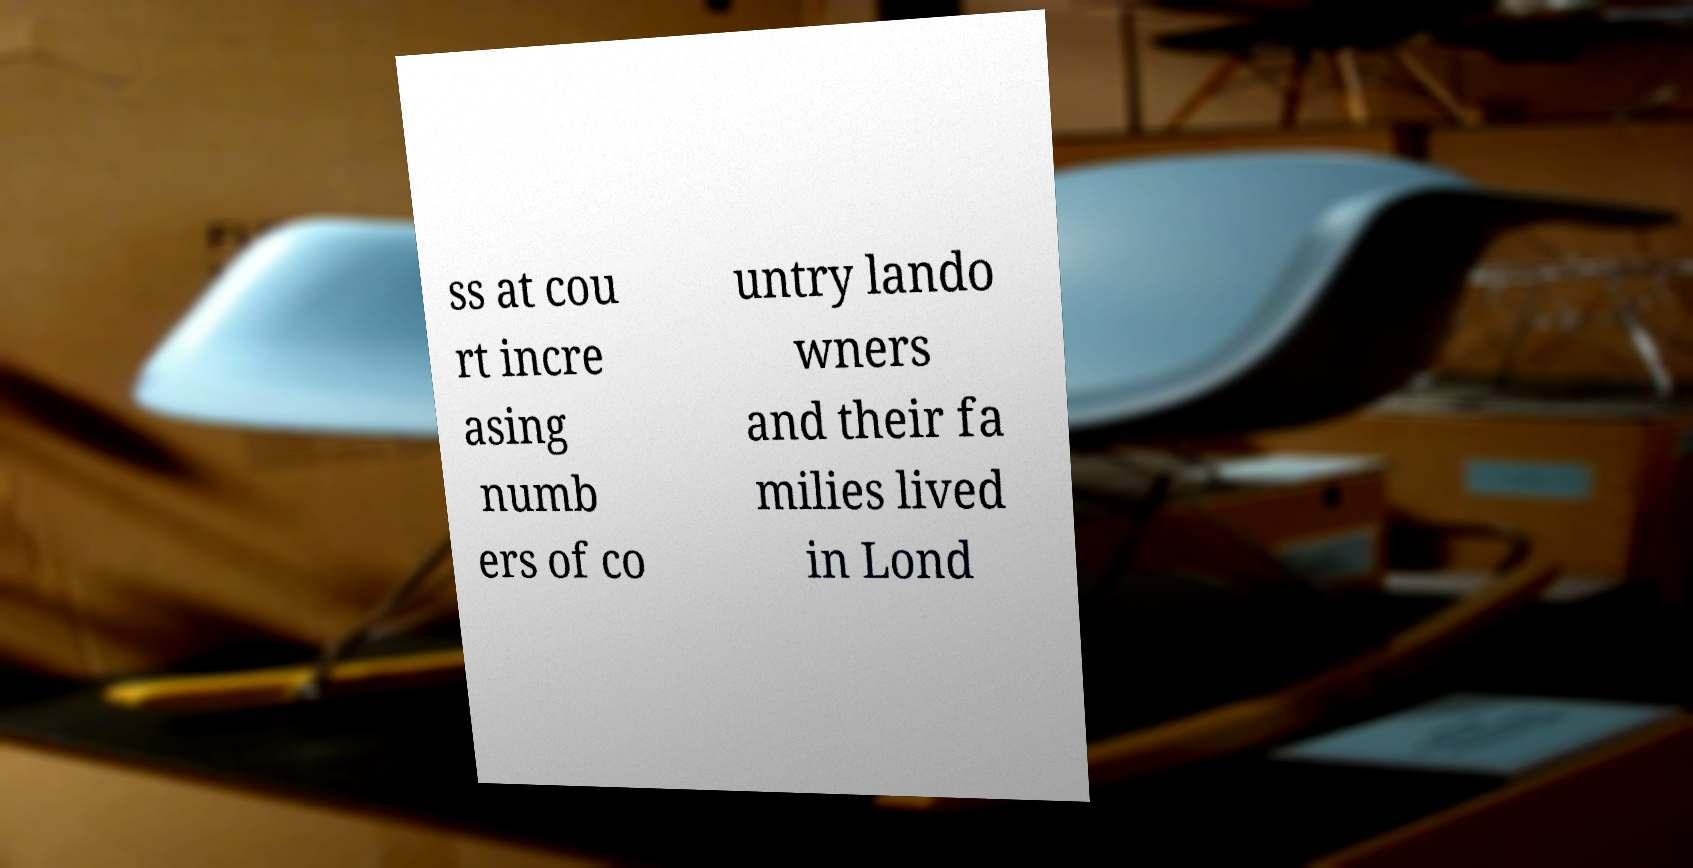Can you accurately transcribe the text from the provided image for me? ss at cou rt incre asing numb ers of co untry lando wners and their fa milies lived in Lond 